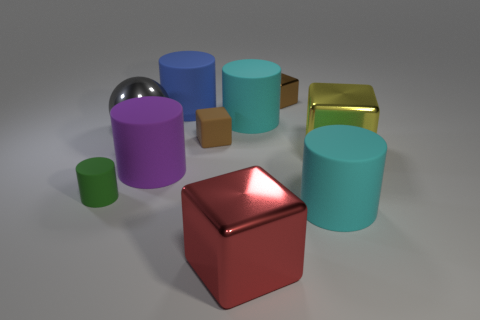Subtract all brown matte blocks. How many blocks are left? 3 Subtract all green spheres. How many brown cubes are left? 2 Subtract all blue cylinders. How many cylinders are left? 4 Subtract all cyan blocks. Subtract all red spheres. How many blocks are left? 4 Subtract all blocks. How many objects are left? 6 Subtract all large green shiny cylinders. Subtract all large purple things. How many objects are left? 9 Add 9 brown shiny blocks. How many brown shiny blocks are left? 10 Add 9 gray metallic objects. How many gray metallic objects exist? 10 Subtract 0 blue spheres. How many objects are left? 10 